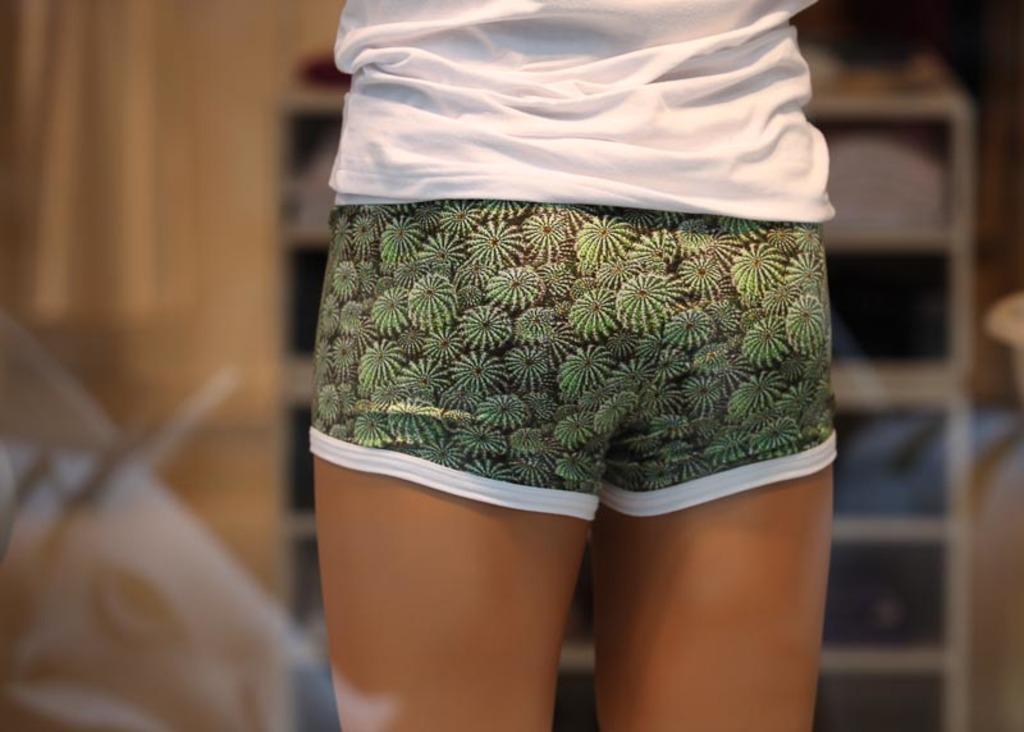Please provide a concise description of this image. There are legs of a person. The person is wearing shorts and a white t shirt. The background is blurred. 